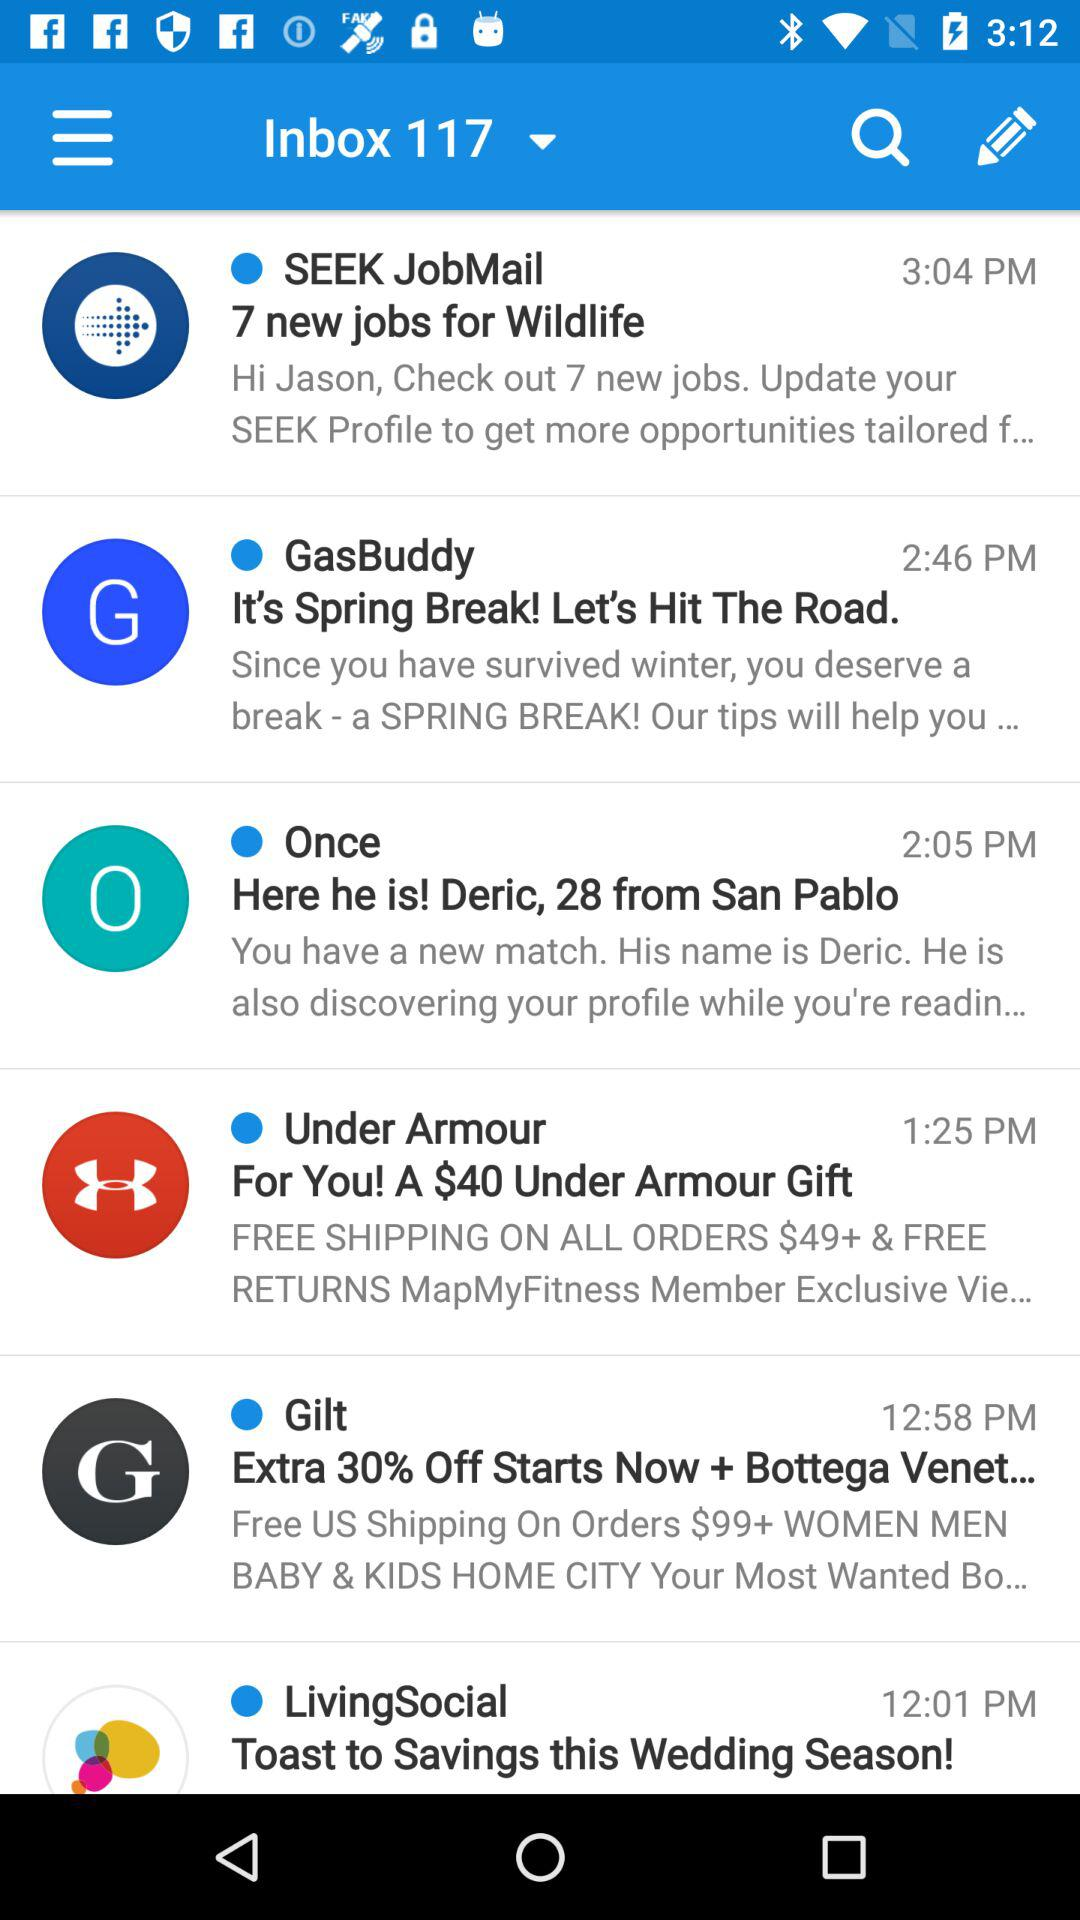How many emails have been deleted?
When the provided information is insufficient, respond with <no answer>. <no answer> 